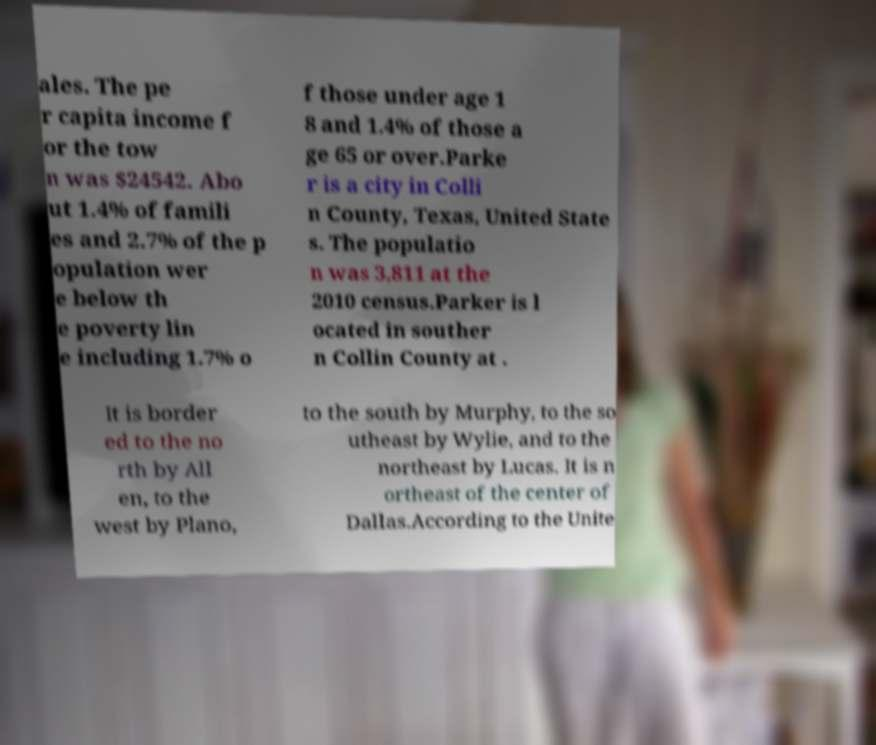Please read and relay the text visible in this image. What does it say? ales. The pe r capita income f or the tow n was $24542. Abo ut 1.4% of famili es and 2.7% of the p opulation wer e below th e poverty lin e including 1.7% o f those under age 1 8 and 1.4% of those a ge 65 or over.Parke r is a city in Colli n County, Texas, United State s. The populatio n was 3,811 at the 2010 census.Parker is l ocated in souther n Collin County at . It is border ed to the no rth by All en, to the west by Plano, to the south by Murphy, to the so utheast by Wylie, and to the northeast by Lucas. It is n ortheast of the center of Dallas.According to the Unite 